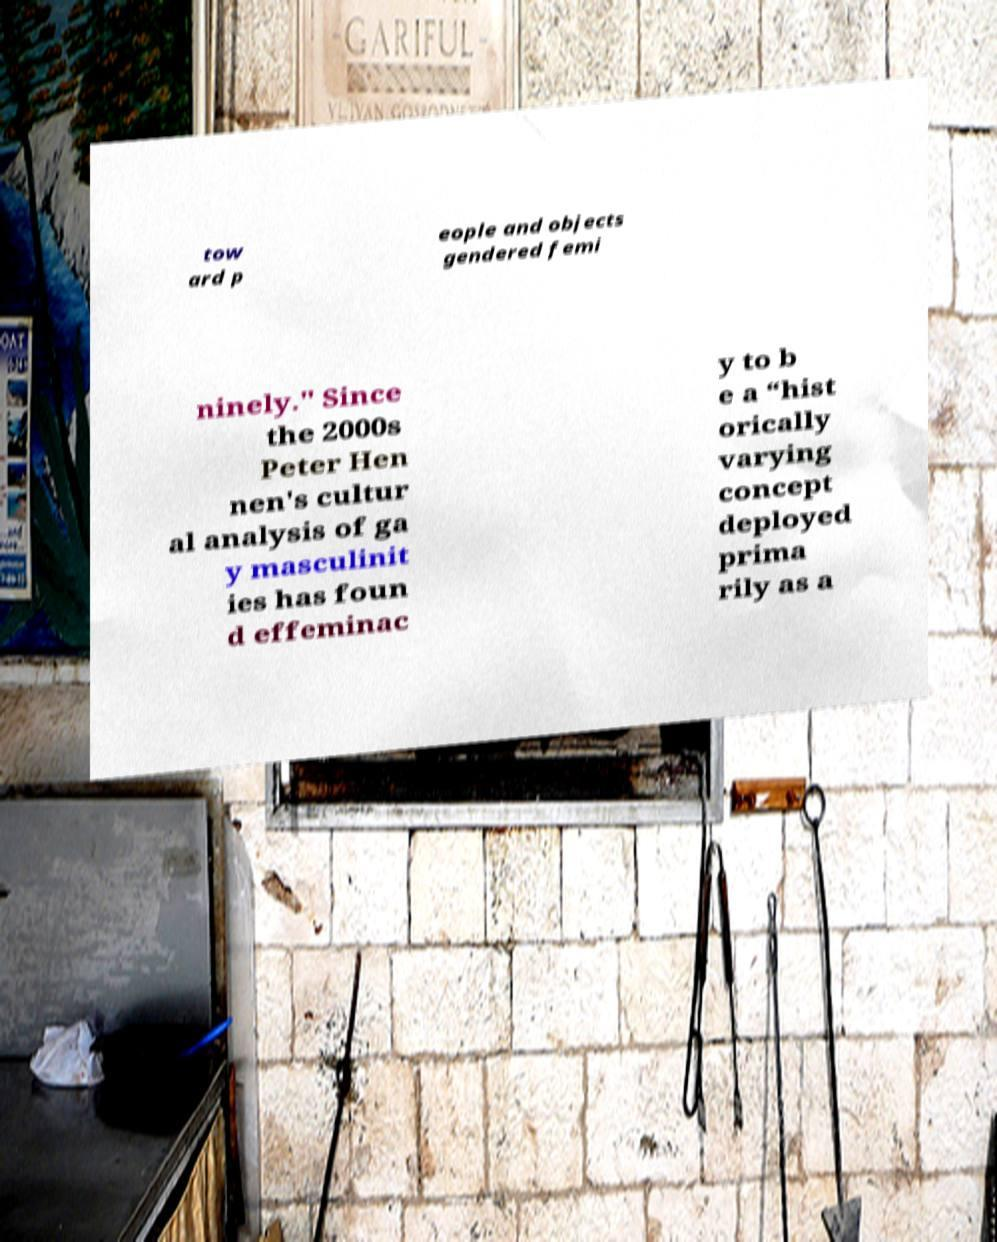For documentation purposes, I need the text within this image transcribed. Could you provide that? tow ard p eople and objects gendered femi ninely." Since the 2000s Peter Hen nen's cultur al analysis of ga y masculinit ies has foun d effeminac y to b e a “hist orically varying concept deployed prima rily as a 